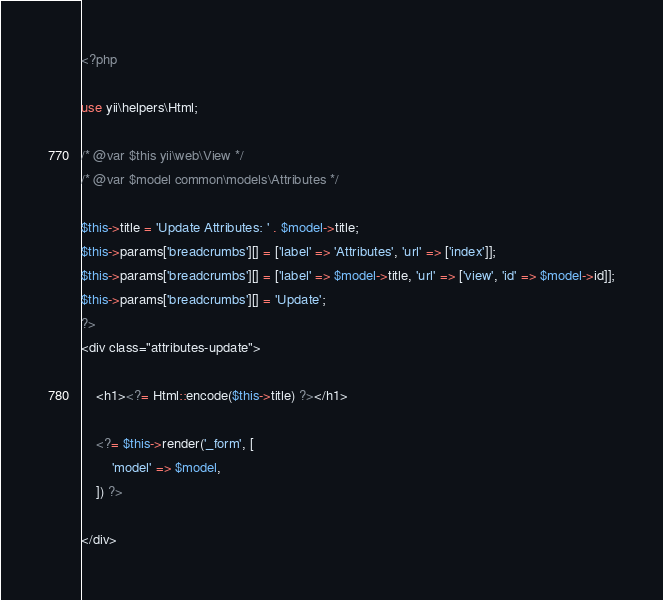Convert code to text. <code><loc_0><loc_0><loc_500><loc_500><_PHP_><?php

use yii\helpers\Html;

/* @var $this yii\web\View */
/* @var $model common\models\Attributes */

$this->title = 'Update Attributes: ' . $model->title;
$this->params['breadcrumbs'][] = ['label' => 'Attributes', 'url' => ['index']];
$this->params['breadcrumbs'][] = ['label' => $model->title, 'url' => ['view', 'id' => $model->id]];
$this->params['breadcrumbs'][] = 'Update';
?>
<div class="attributes-update">

    <h1><?= Html::encode($this->title) ?></h1>

    <?= $this->render('_form', [
        'model' => $model,
    ]) ?>

</div>
</code> 